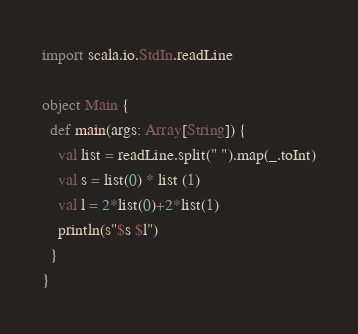<code> <loc_0><loc_0><loc_500><loc_500><_Scala_>import scala.io.StdIn.readLine

object Main {
  def main(args: Array[String]) {
    val list = readLine.split(" ").map(_.toInt)
    val s = list(0) * list (1)
    val l = 2*list(0)+2*list(1)
    println(s"$s $l")
  }
}</code> 